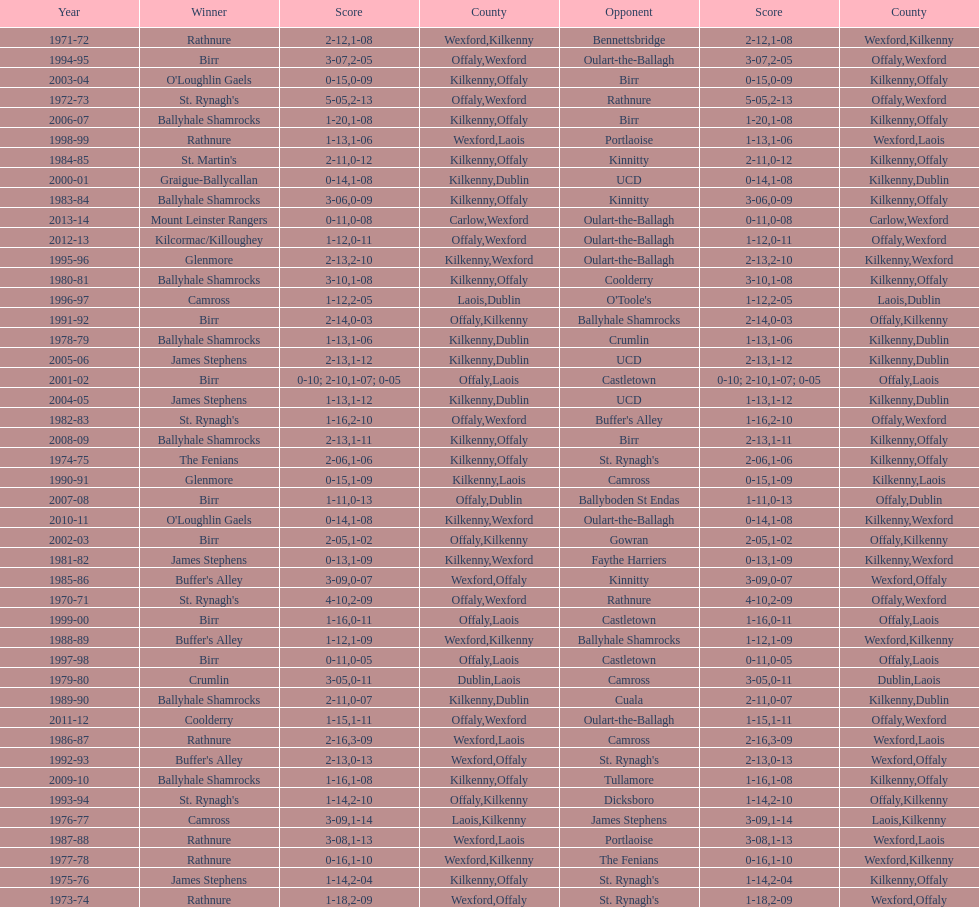Can you parse all the data within this table? {'header': ['Year', 'Winner', 'Score', 'County', 'Opponent', 'Score', 'County'], 'rows': [['1971-72', 'Rathnure', '2-12', 'Wexford', 'Bennettsbridge', '1-08', 'Kilkenny'], ['1994-95', 'Birr', '3-07', 'Offaly', 'Oulart-the-Ballagh', '2-05', 'Wexford'], ['2003-04', "O'Loughlin Gaels", '0-15', 'Kilkenny', 'Birr', '0-09', 'Offaly'], ['1972-73', "St. Rynagh's", '5-05', 'Offaly', 'Rathnure', '2-13', 'Wexford'], ['2006-07', 'Ballyhale Shamrocks', '1-20', 'Kilkenny', 'Birr', '1-08', 'Offaly'], ['1998-99', 'Rathnure', '1-13', 'Wexford', 'Portlaoise', '1-06', 'Laois'], ['1984-85', "St. Martin's", '2-11', 'Kilkenny', 'Kinnitty', '0-12', 'Offaly'], ['2000-01', 'Graigue-Ballycallan', '0-14', 'Kilkenny', 'UCD', '1-08', 'Dublin'], ['1983-84', 'Ballyhale Shamrocks', '3-06', 'Kilkenny', 'Kinnitty', '0-09', 'Offaly'], ['2013-14', 'Mount Leinster Rangers', '0-11', 'Carlow', 'Oulart-the-Ballagh', '0-08', 'Wexford'], ['2012-13', 'Kilcormac/Killoughey', '1-12', 'Offaly', 'Oulart-the-Ballagh', '0-11', 'Wexford'], ['1995-96', 'Glenmore', '2-13', 'Kilkenny', 'Oulart-the-Ballagh', '2-10', 'Wexford'], ['1980-81', 'Ballyhale Shamrocks', '3-10', 'Kilkenny', 'Coolderry', '1-08', 'Offaly'], ['1996-97', 'Camross', '1-12', 'Laois', "O'Toole's", '2-05', 'Dublin'], ['1991-92', 'Birr', '2-14', 'Offaly', 'Ballyhale Shamrocks', '0-03', 'Kilkenny'], ['1978-79', 'Ballyhale Shamrocks', '1-13', 'Kilkenny', 'Crumlin', '1-06', 'Dublin'], ['2005-06', 'James Stephens', '2-13', 'Kilkenny', 'UCD', '1-12', 'Dublin'], ['2001-02', 'Birr', '0-10; 2-10', 'Offaly', 'Castletown', '1-07; 0-05', 'Laois'], ['2004-05', 'James Stephens', '1-13', 'Kilkenny', 'UCD', '1-12', 'Dublin'], ['1982-83', "St. Rynagh's", '1-16', 'Offaly', "Buffer's Alley", '2-10', 'Wexford'], ['2008-09', 'Ballyhale Shamrocks', '2-13', 'Kilkenny', 'Birr', '1-11', 'Offaly'], ['1974-75', 'The Fenians', '2-06', 'Kilkenny', "St. Rynagh's", '1-06', 'Offaly'], ['1990-91', 'Glenmore', '0-15', 'Kilkenny', 'Camross', '1-09', 'Laois'], ['2007-08', 'Birr', '1-11', 'Offaly', 'Ballyboden St Endas', '0-13', 'Dublin'], ['2010-11', "O'Loughlin Gaels", '0-14', 'Kilkenny', 'Oulart-the-Ballagh', '1-08', 'Wexford'], ['2002-03', 'Birr', '2-05', 'Offaly', 'Gowran', '1-02', 'Kilkenny'], ['1981-82', 'James Stephens', '0-13', 'Kilkenny', 'Faythe Harriers', '1-09', 'Wexford'], ['1985-86', "Buffer's Alley", '3-09', 'Wexford', 'Kinnitty', '0-07', 'Offaly'], ['1970-71', "St. Rynagh's", '4-10', 'Offaly', 'Rathnure', '2-09', 'Wexford'], ['1999-00', 'Birr', '1-16', 'Offaly', 'Castletown', '0-11', 'Laois'], ['1988-89', "Buffer's Alley", '1-12', 'Wexford', 'Ballyhale Shamrocks', '1-09', 'Kilkenny'], ['1997-98', 'Birr', '0-11', 'Offaly', 'Castletown', '0-05', 'Laois'], ['1979-80', 'Crumlin', '3-05', 'Dublin', 'Camross', '0-11', 'Laois'], ['1989-90', 'Ballyhale Shamrocks', '2-11', 'Kilkenny', 'Cuala', '0-07', 'Dublin'], ['2011-12', 'Coolderry', '1-15', 'Offaly', 'Oulart-the-Ballagh', '1-11', 'Wexford'], ['1986-87', 'Rathnure', '2-16', 'Wexford', 'Camross', '3-09', 'Laois'], ['1992-93', "Buffer's Alley", '2-13', 'Wexford', "St. Rynagh's", '0-13', 'Offaly'], ['2009-10', 'Ballyhale Shamrocks', '1-16', 'Kilkenny', 'Tullamore', '1-08', 'Offaly'], ['1993-94', "St. Rynagh's", '1-14', 'Offaly', 'Dicksboro', '2-10', 'Kilkenny'], ['1976-77', 'Camross', '3-09', 'Laois', 'James Stephens', '1-14', 'Kilkenny'], ['1987-88', 'Rathnure', '3-08', 'Wexford', 'Portlaoise', '1-13', 'Laois'], ['1977-78', 'Rathnure', '0-16', 'Wexford', 'The Fenians', '1-10', 'Kilkenny'], ['1975-76', 'James Stephens', '1-14', 'Kilkenny', "St. Rynagh's", '2-04', 'Offaly'], ['1973-74', 'Rathnure', '1-18', 'Wexford', "St. Rynagh's", '2-09', 'Offaly']]} Which team won the leinster senior club hurling championships previous to the last time birr won? Ballyhale Shamrocks. 